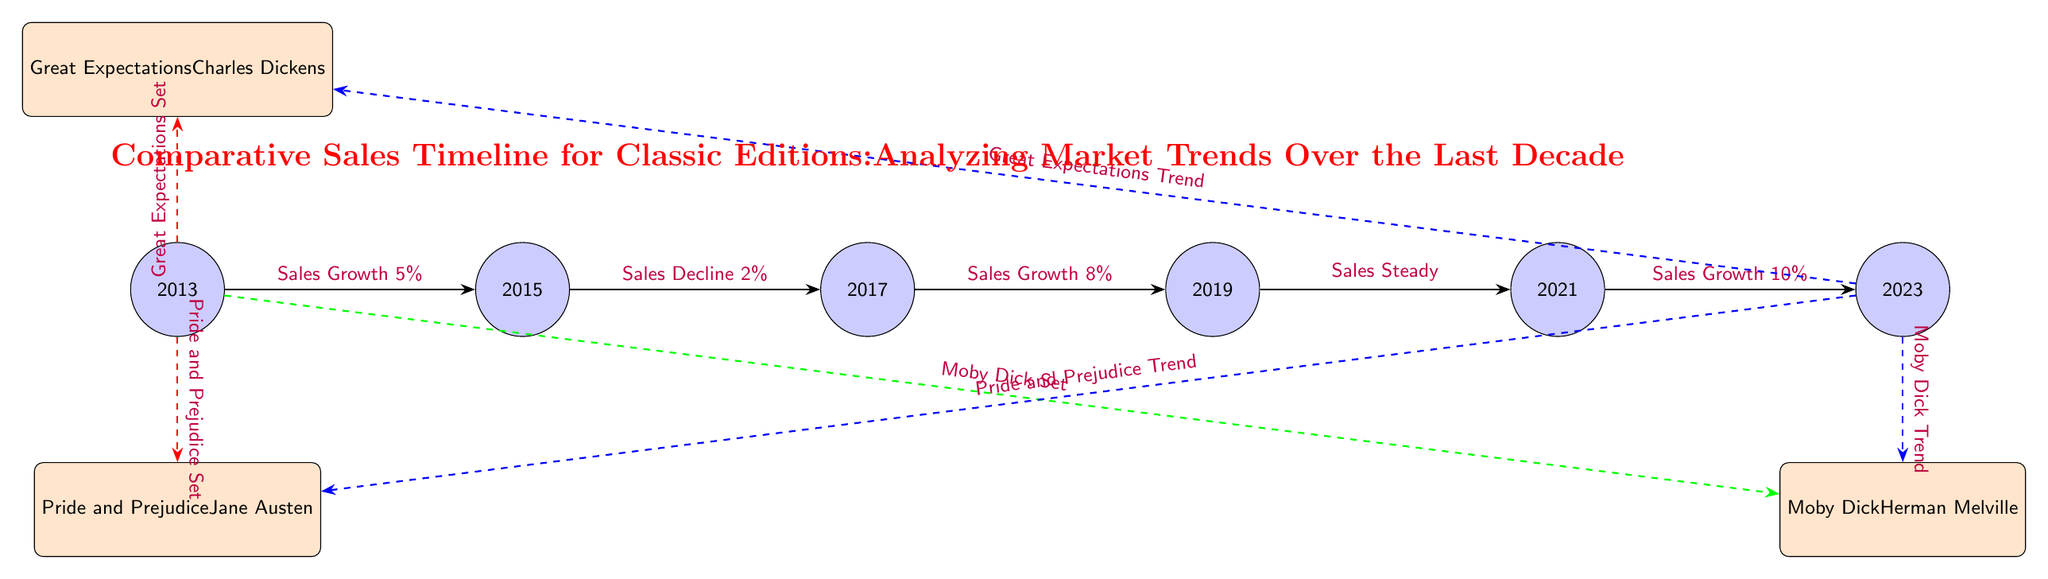What year showed a sales decline? According to the diagram, the year that experienced a sales decline is 2015, as indicated by the edge labeled "Sales Decline 2%" pointing from 2015 to 2017.
Answer: 2015 Which book had a sales growth of 10% by 2023? The diagram illustrates the "Sales Growth 10%" edge from 2021 to 2023, linking specifically to the book "Great Expectations," which has a dashed blue line indicating its trend.
Answer: Great Expectations How many books are associated with the sales data in 2013? The diagram shows two dashed red lines connecting the year 2013 to two books: "Great Expectations" and "Pride and Prejudice." Thus, there are two books associated with the sales data for that year.
Answer: 2 What was the overall sales trend from 2013 to 2023? To determine the overall trend, we observe the sequence of changes: starting with a growth of 5%, followed by a decline, then growth of 8%, steady sales, and finally a growth of 10%. This indicates an overall positive trend towards the end.
Answer: Positive Which book shows a sales trend in 2023? In the diagram, all three books - "Great Expectations," "Pride and Prejudice," and "Moby Dick" - exhibit sales trends through the dashed blue lines extending from 2023, indicating they are all analyzed in that year.
Answer: All three What was the sales growth percentage from 2017 to 2019? The edge labeled "Sales Growth 8%" directly connects the years 2017 and 2019, clearly indicating the percentage growth during that period.
Answer: 8% Which book recorded sales data in 2023? The visual representation indicates that all three books are connected to the year 2023 with sales trends, meaning each one has recorded data relevant to that year.
Answer: All three books What type of trend did "Pride and Prejudice" experience by 2023? The diagram connects "Pride and Prejudice" to 2023 with a dashed blue edge that indicates a trend, meaning it charted some sales data leading up to that year. Thus, its trend indicates an analysis of its sales performance into 2023.
Answer: Trend 